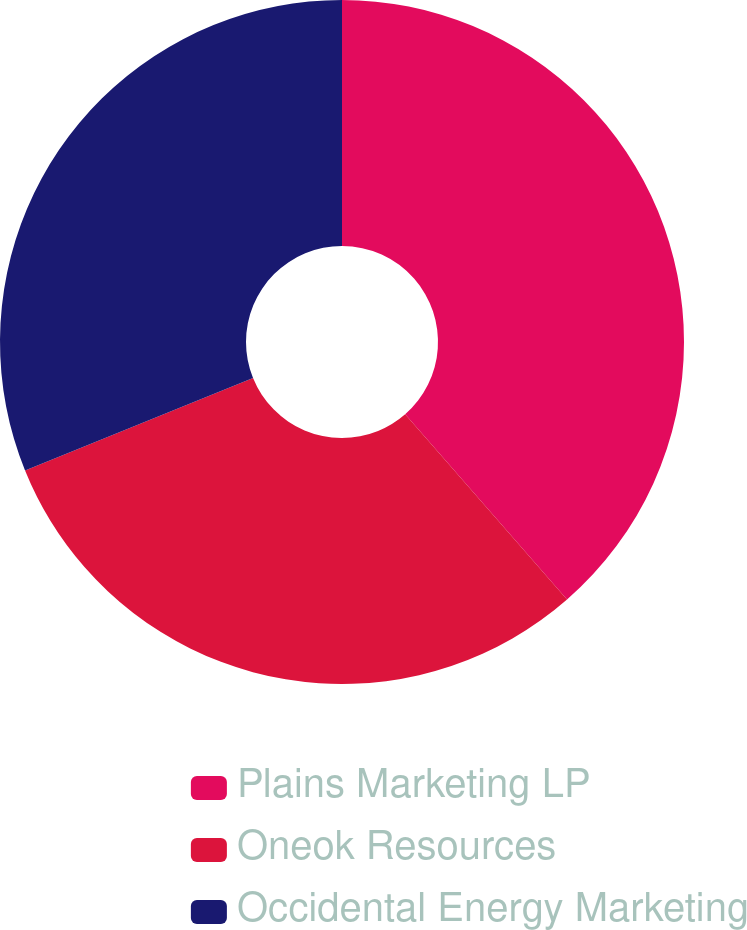<chart> <loc_0><loc_0><loc_500><loc_500><pie_chart><fcel>Plains Marketing LP<fcel>Oneok Resources<fcel>Occidental Energy Marketing<nl><fcel>38.57%<fcel>30.3%<fcel>31.13%<nl></chart> 